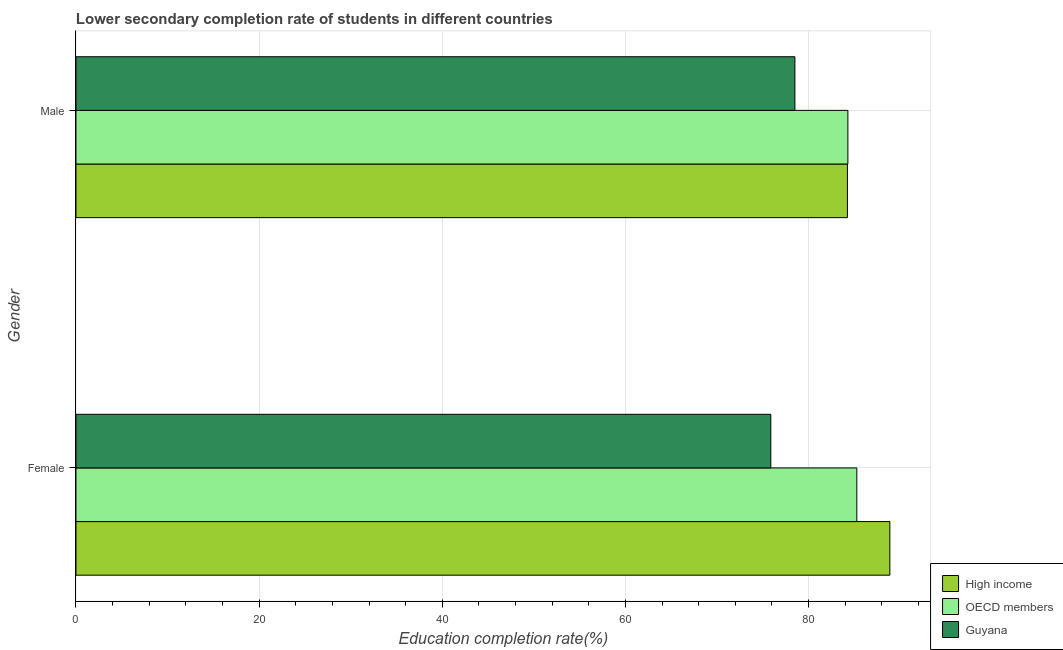How many different coloured bars are there?
Provide a succinct answer. 3. How many bars are there on the 2nd tick from the top?
Make the answer very short. 3. How many bars are there on the 2nd tick from the bottom?
Your response must be concise. 3. What is the education completion rate of male students in Guyana?
Offer a very short reply. 78.51. Across all countries, what is the maximum education completion rate of female students?
Offer a very short reply. 88.88. Across all countries, what is the minimum education completion rate of male students?
Keep it short and to the point. 78.51. In which country was the education completion rate of male students minimum?
Your response must be concise. Guyana. What is the total education completion rate of female students in the graph?
Provide a short and direct response. 250.02. What is the difference between the education completion rate of male students in High income and that in OECD members?
Provide a short and direct response. -0.05. What is the difference between the education completion rate of male students in High income and the education completion rate of female students in Guyana?
Make the answer very short. 8.37. What is the average education completion rate of female students per country?
Make the answer very short. 83.34. What is the difference between the education completion rate of female students and education completion rate of male students in OECD members?
Provide a short and direct response. 0.98. What is the ratio of the education completion rate of female students in Guyana to that in OECD members?
Your answer should be compact. 0.89. In how many countries, is the education completion rate of male students greater than the average education completion rate of male students taken over all countries?
Offer a terse response. 2. What does the 2nd bar from the top in Male represents?
Your answer should be compact. OECD members. What does the 3rd bar from the bottom in Female represents?
Your answer should be very brief. Guyana. How many bars are there?
Ensure brevity in your answer.  6. How many countries are there in the graph?
Provide a short and direct response. 3. What is the difference between two consecutive major ticks on the X-axis?
Your answer should be compact. 20. How many legend labels are there?
Make the answer very short. 3. What is the title of the graph?
Give a very brief answer. Lower secondary completion rate of students in different countries. What is the label or title of the X-axis?
Provide a succinct answer. Education completion rate(%). What is the label or title of the Y-axis?
Your answer should be very brief. Gender. What is the Education completion rate(%) in High income in Female?
Keep it short and to the point. 88.88. What is the Education completion rate(%) of OECD members in Female?
Provide a succinct answer. 85.27. What is the Education completion rate(%) in Guyana in Female?
Provide a short and direct response. 75.88. What is the Education completion rate(%) in High income in Male?
Your answer should be compact. 84.24. What is the Education completion rate(%) in OECD members in Male?
Keep it short and to the point. 84.29. What is the Education completion rate(%) in Guyana in Male?
Offer a very short reply. 78.51. Across all Gender, what is the maximum Education completion rate(%) of High income?
Your answer should be compact. 88.88. Across all Gender, what is the maximum Education completion rate(%) of OECD members?
Keep it short and to the point. 85.27. Across all Gender, what is the maximum Education completion rate(%) of Guyana?
Offer a terse response. 78.51. Across all Gender, what is the minimum Education completion rate(%) of High income?
Offer a very short reply. 84.24. Across all Gender, what is the minimum Education completion rate(%) in OECD members?
Your answer should be compact. 84.29. Across all Gender, what is the minimum Education completion rate(%) in Guyana?
Your answer should be very brief. 75.88. What is the total Education completion rate(%) of High income in the graph?
Your response must be concise. 173.12. What is the total Education completion rate(%) in OECD members in the graph?
Your response must be concise. 169.56. What is the total Education completion rate(%) of Guyana in the graph?
Make the answer very short. 154.38. What is the difference between the Education completion rate(%) of High income in Female and that in Male?
Keep it short and to the point. 4.63. What is the difference between the Education completion rate(%) of OECD members in Female and that in Male?
Your answer should be very brief. 0.98. What is the difference between the Education completion rate(%) of Guyana in Female and that in Male?
Give a very brief answer. -2.63. What is the difference between the Education completion rate(%) in High income in Female and the Education completion rate(%) in OECD members in Male?
Your response must be concise. 4.58. What is the difference between the Education completion rate(%) of High income in Female and the Education completion rate(%) of Guyana in Male?
Ensure brevity in your answer.  10.37. What is the difference between the Education completion rate(%) of OECD members in Female and the Education completion rate(%) of Guyana in Male?
Provide a short and direct response. 6.76. What is the average Education completion rate(%) of High income per Gender?
Make the answer very short. 86.56. What is the average Education completion rate(%) in OECD members per Gender?
Your answer should be very brief. 84.78. What is the average Education completion rate(%) in Guyana per Gender?
Give a very brief answer. 77.19. What is the difference between the Education completion rate(%) in High income and Education completion rate(%) in OECD members in Female?
Your response must be concise. 3.61. What is the difference between the Education completion rate(%) in High income and Education completion rate(%) in Guyana in Female?
Offer a terse response. 13. What is the difference between the Education completion rate(%) of OECD members and Education completion rate(%) of Guyana in Female?
Your response must be concise. 9.39. What is the difference between the Education completion rate(%) of High income and Education completion rate(%) of OECD members in Male?
Keep it short and to the point. -0.05. What is the difference between the Education completion rate(%) in High income and Education completion rate(%) in Guyana in Male?
Provide a short and direct response. 5.74. What is the difference between the Education completion rate(%) in OECD members and Education completion rate(%) in Guyana in Male?
Make the answer very short. 5.79. What is the ratio of the Education completion rate(%) of High income in Female to that in Male?
Make the answer very short. 1.05. What is the ratio of the Education completion rate(%) of OECD members in Female to that in Male?
Make the answer very short. 1.01. What is the ratio of the Education completion rate(%) of Guyana in Female to that in Male?
Ensure brevity in your answer.  0.97. What is the difference between the highest and the second highest Education completion rate(%) of High income?
Your response must be concise. 4.63. What is the difference between the highest and the second highest Education completion rate(%) in OECD members?
Ensure brevity in your answer.  0.98. What is the difference between the highest and the second highest Education completion rate(%) in Guyana?
Your answer should be very brief. 2.63. What is the difference between the highest and the lowest Education completion rate(%) of High income?
Offer a terse response. 4.63. What is the difference between the highest and the lowest Education completion rate(%) in OECD members?
Ensure brevity in your answer.  0.98. What is the difference between the highest and the lowest Education completion rate(%) of Guyana?
Offer a very short reply. 2.63. 